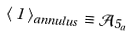<formula> <loc_0><loc_0><loc_500><loc_500>\langle \, 1 \, \rangle _ { a n n u l u s } \equiv \mathcal { A } _ { 5 _ { a } }</formula> 